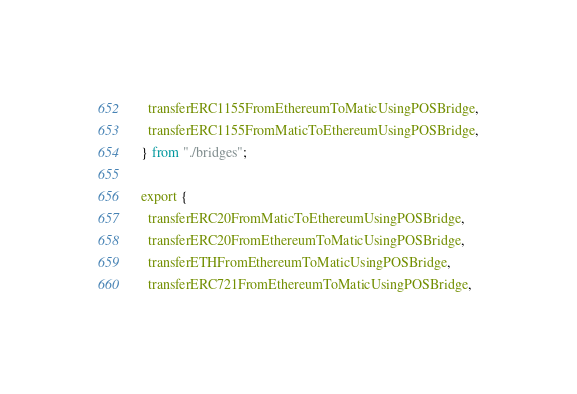<code> <loc_0><loc_0><loc_500><loc_500><_TypeScript_>  transferERC1155FromEthereumToMaticUsingPOSBridge,
  transferERC1155FromMaticToEthereumUsingPOSBridge,
} from "./bridges";

export {
  transferERC20FromMaticToEthereumUsingPOSBridge,
  transferERC20FromEthereumToMaticUsingPOSBridge,
  transferETHFromEthereumToMaticUsingPOSBridge,
  transferERC721FromEthereumToMaticUsingPOSBridge,</code> 